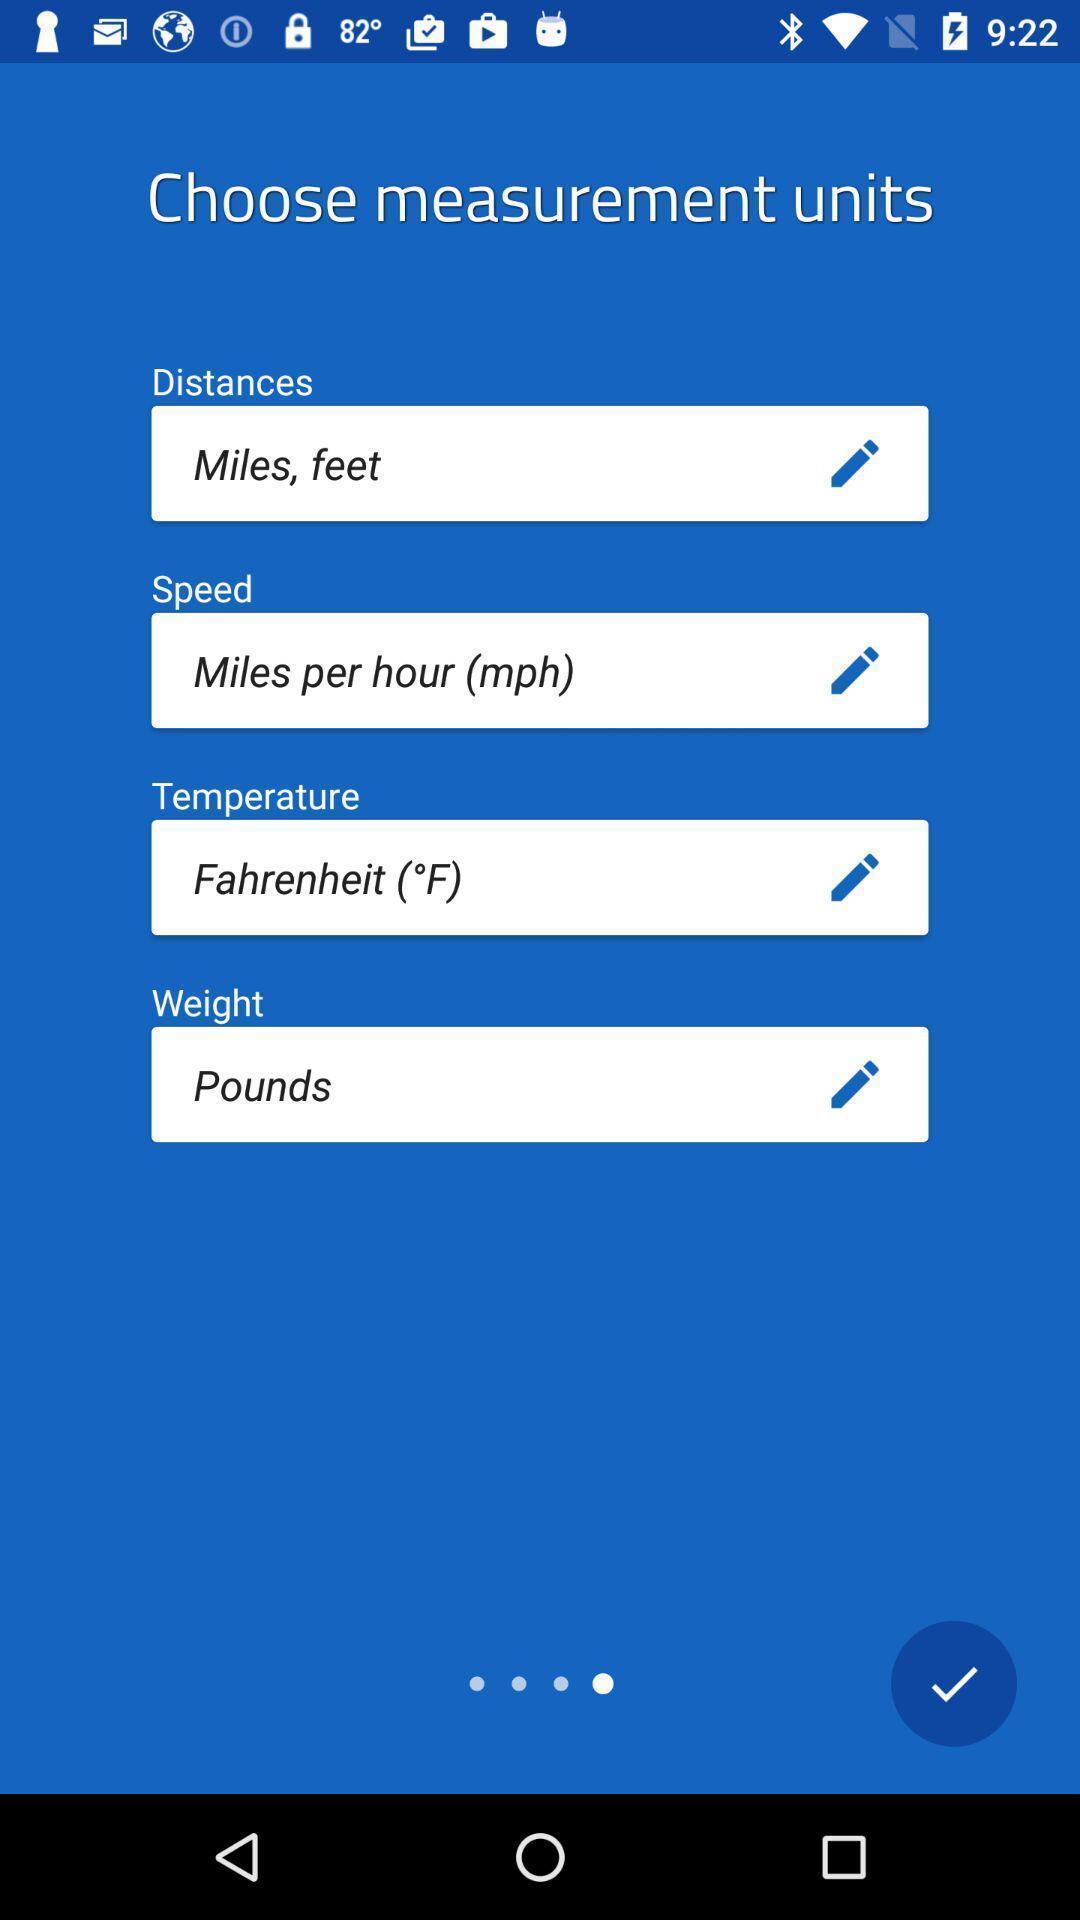Please provide a description for this image. Page showing the input fields for measurements. 